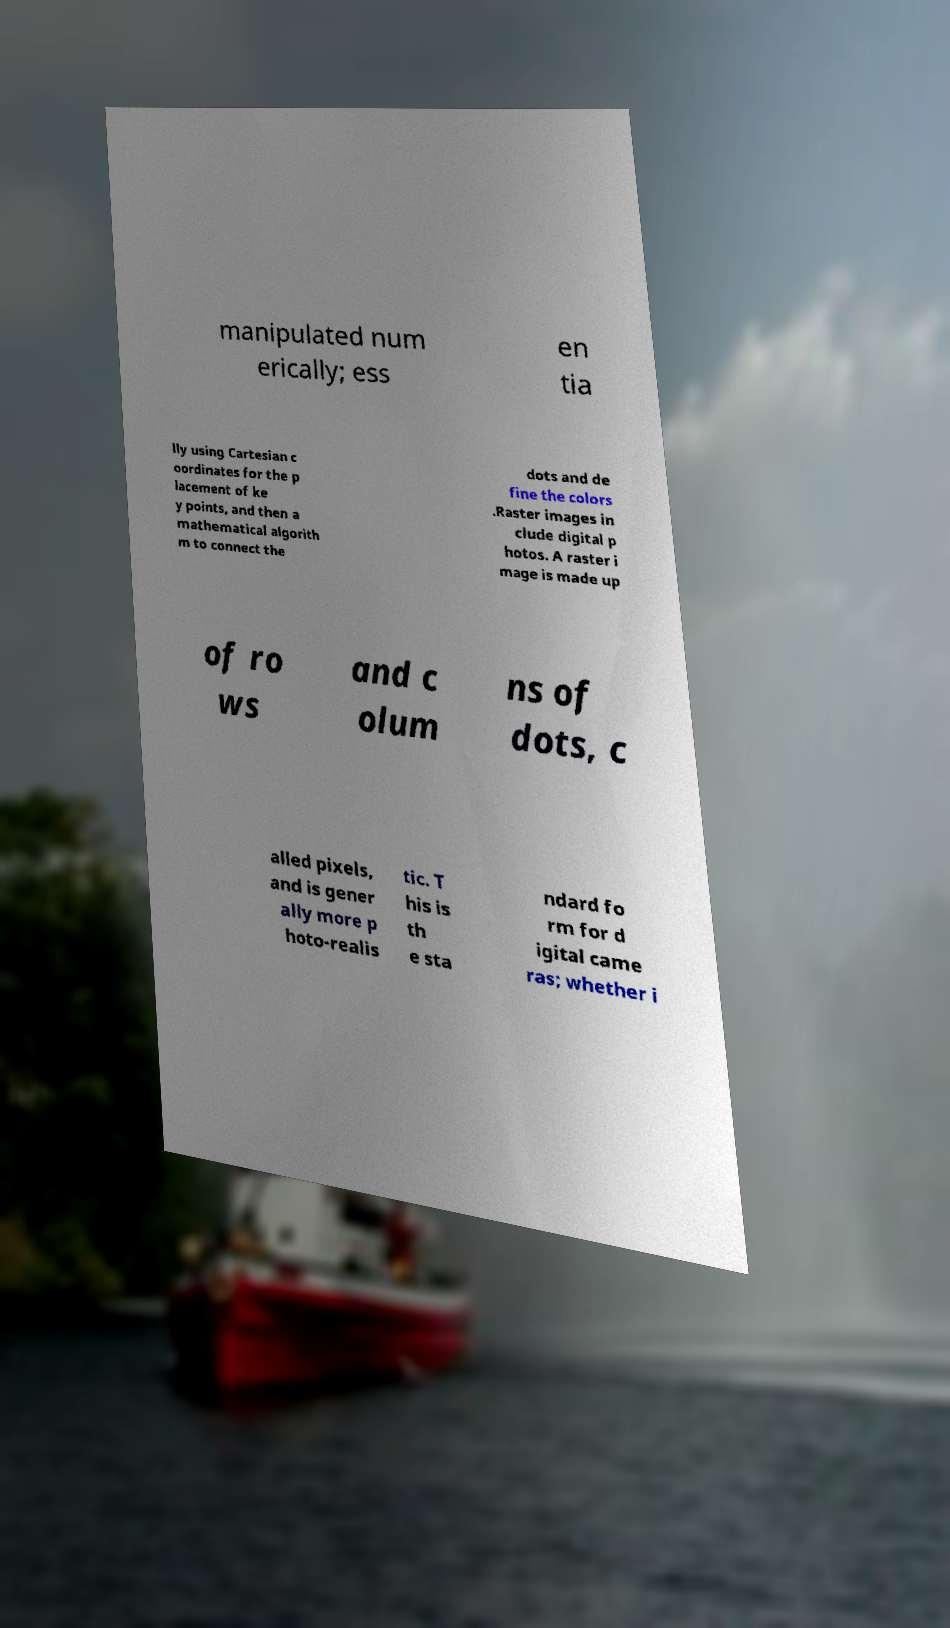Please read and relay the text visible in this image. What does it say? manipulated num erically; ess en tia lly using Cartesian c oordinates for the p lacement of ke y points, and then a mathematical algorith m to connect the dots and de fine the colors .Raster images in clude digital p hotos. A raster i mage is made up of ro ws and c olum ns of dots, c alled pixels, and is gener ally more p hoto-realis tic. T his is th e sta ndard fo rm for d igital came ras; whether i 